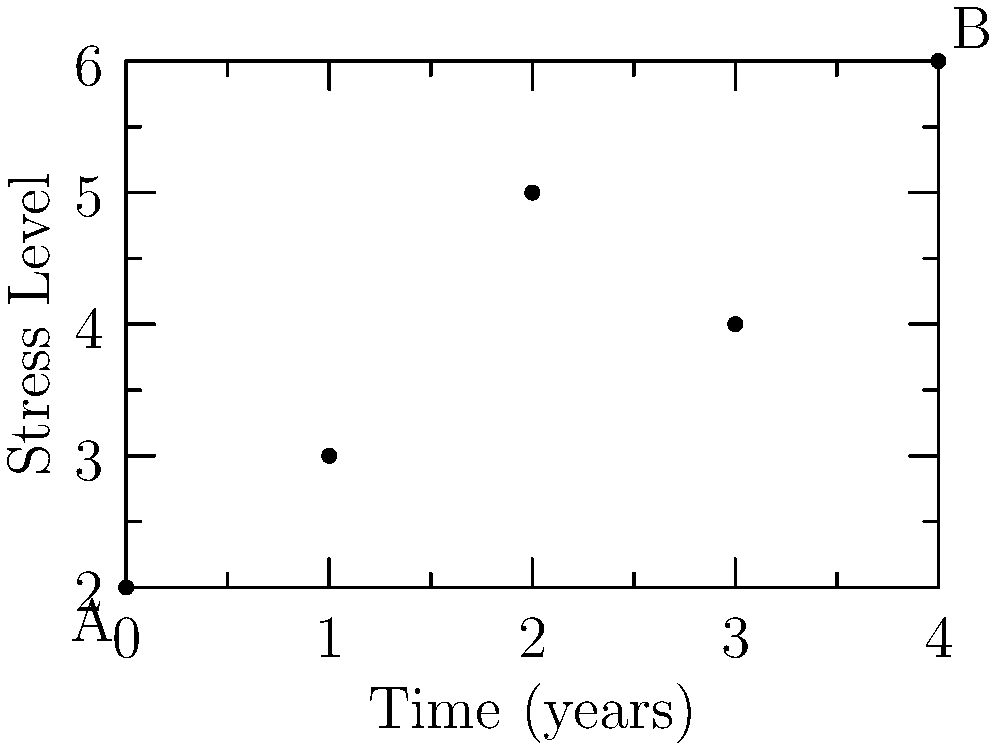Given the vector representation of student stress levels over time, calculate the average rate of change in stress levels from point A to point B. How does this relate to the growing concern about mental health issues among young people? To calculate the average rate of change in stress levels from point A to point B:

1. Identify the coordinates:
   Point A: $(0, 2)$
   Point B: $(4, 6)$

2. Calculate the change in stress level (vertical change):
   $\Delta y = 6 - 2 = 4$

3. Calculate the change in time (horizontal change):
   $\Delta x = 4 - 0 = 4$ years

4. Apply the formula for average rate of change:
   Average rate of change = $\frac{\Delta y}{\Delta x} = \frac{4}{4} = 1$

The average rate of change is 1 stress unit per year.

This result indicates a consistent increase in stress levels among students over time. The positive rate of change aligns with the growing concern about mental health issues among young people, as it shows a clear upward trend in stress levels. This data supports the educator's shock at the mental health crisis, highlighting the need for interventions and support systems in educational institutions.
Answer: 1 stress unit per year 